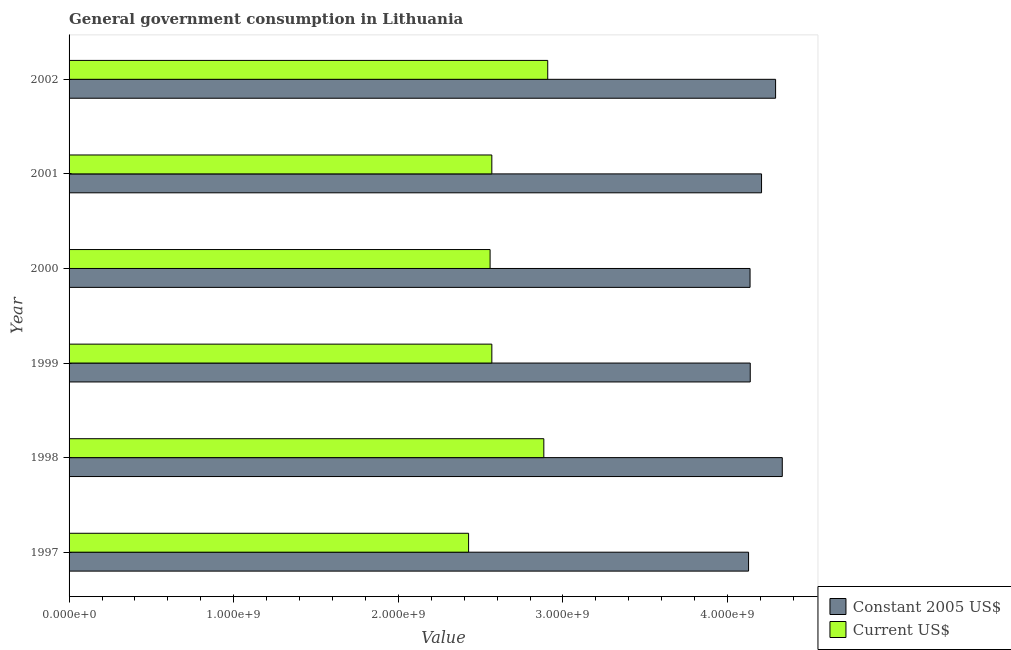Are the number of bars per tick equal to the number of legend labels?
Offer a very short reply. Yes. Are the number of bars on each tick of the Y-axis equal?
Provide a succinct answer. Yes. What is the value consumed in constant 2005 us$ in 2001?
Your answer should be compact. 4.21e+09. Across all years, what is the maximum value consumed in constant 2005 us$?
Offer a terse response. 4.33e+09. Across all years, what is the minimum value consumed in current us$?
Offer a terse response. 2.43e+09. In which year was the value consumed in constant 2005 us$ minimum?
Offer a terse response. 1997. What is the total value consumed in current us$ in the graph?
Ensure brevity in your answer.  1.59e+1. What is the difference between the value consumed in constant 2005 us$ in 1999 and that in 2001?
Your answer should be very brief. -6.86e+07. What is the difference between the value consumed in constant 2005 us$ in 1997 and the value consumed in current us$ in 2000?
Your answer should be compact. 1.57e+09. What is the average value consumed in constant 2005 us$ per year?
Offer a very short reply. 4.21e+09. In the year 2000, what is the difference between the value consumed in constant 2005 us$ and value consumed in current us$?
Keep it short and to the point. 1.58e+09. In how many years, is the value consumed in constant 2005 us$ greater than 3000000000 ?
Provide a succinct answer. 6. What is the ratio of the value consumed in constant 2005 us$ in 1997 to that in 1998?
Offer a very short reply. 0.95. What is the difference between the highest and the second highest value consumed in constant 2005 us$?
Provide a short and direct response. 4.07e+07. What is the difference between the highest and the lowest value consumed in constant 2005 us$?
Ensure brevity in your answer.  2.05e+08. In how many years, is the value consumed in current us$ greater than the average value consumed in current us$ taken over all years?
Your response must be concise. 2. What does the 2nd bar from the top in 2002 represents?
Offer a very short reply. Constant 2005 US$. What does the 1st bar from the bottom in 2001 represents?
Provide a succinct answer. Constant 2005 US$. How many bars are there?
Your response must be concise. 12. Are all the bars in the graph horizontal?
Offer a very short reply. Yes. How many legend labels are there?
Offer a very short reply. 2. What is the title of the graph?
Offer a terse response. General government consumption in Lithuania. Does "Public credit registry" appear as one of the legend labels in the graph?
Offer a terse response. No. What is the label or title of the X-axis?
Your answer should be very brief. Value. What is the label or title of the Y-axis?
Your response must be concise. Year. What is the Value of Constant 2005 US$ in 1997?
Provide a succinct answer. 4.13e+09. What is the Value in Current US$ in 1997?
Keep it short and to the point. 2.43e+09. What is the Value of Constant 2005 US$ in 1998?
Your answer should be very brief. 4.33e+09. What is the Value of Current US$ in 1998?
Your answer should be very brief. 2.88e+09. What is the Value of Constant 2005 US$ in 1999?
Make the answer very short. 4.14e+09. What is the Value in Current US$ in 1999?
Provide a succinct answer. 2.57e+09. What is the Value of Constant 2005 US$ in 2000?
Provide a short and direct response. 4.14e+09. What is the Value in Current US$ in 2000?
Make the answer very short. 2.56e+09. What is the Value of Constant 2005 US$ in 2001?
Ensure brevity in your answer.  4.21e+09. What is the Value of Current US$ in 2001?
Offer a very short reply. 2.57e+09. What is the Value of Constant 2005 US$ in 2002?
Keep it short and to the point. 4.29e+09. What is the Value in Current US$ in 2002?
Your answer should be very brief. 2.91e+09. Across all years, what is the maximum Value in Constant 2005 US$?
Your answer should be very brief. 4.33e+09. Across all years, what is the maximum Value of Current US$?
Your answer should be compact. 2.91e+09. Across all years, what is the minimum Value in Constant 2005 US$?
Provide a short and direct response. 4.13e+09. Across all years, what is the minimum Value in Current US$?
Your response must be concise. 2.43e+09. What is the total Value in Constant 2005 US$ in the graph?
Ensure brevity in your answer.  2.52e+1. What is the total Value of Current US$ in the graph?
Offer a very short reply. 1.59e+1. What is the difference between the Value in Constant 2005 US$ in 1997 and that in 1998?
Offer a very short reply. -2.05e+08. What is the difference between the Value of Current US$ in 1997 and that in 1998?
Give a very brief answer. -4.57e+08. What is the difference between the Value in Constant 2005 US$ in 1997 and that in 1999?
Provide a succinct answer. -1.02e+07. What is the difference between the Value in Current US$ in 1997 and that in 1999?
Ensure brevity in your answer.  -1.41e+08. What is the difference between the Value in Constant 2005 US$ in 1997 and that in 2000?
Keep it short and to the point. -9.15e+06. What is the difference between the Value in Current US$ in 1997 and that in 2000?
Keep it short and to the point. -1.31e+08. What is the difference between the Value of Constant 2005 US$ in 1997 and that in 2001?
Offer a very short reply. -7.89e+07. What is the difference between the Value in Current US$ in 1997 and that in 2001?
Provide a short and direct response. -1.41e+08. What is the difference between the Value of Constant 2005 US$ in 1997 and that in 2002?
Provide a short and direct response. -1.64e+08. What is the difference between the Value of Current US$ in 1997 and that in 2002?
Offer a very short reply. -4.81e+08. What is the difference between the Value in Constant 2005 US$ in 1998 and that in 1999?
Your answer should be very brief. 1.95e+08. What is the difference between the Value in Current US$ in 1998 and that in 1999?
Offer a very short reply. 3.16e+08. What is the difference between the Value of Constant 2005 US$ in 1998 and that in 2000?
Ensure brevity in your answer.  1.96e+08. What is the difference between the Value of Current US$ in 1998 and that in 2000?
Keep it short and to the point. 3.26e+08. What is the difference between the Value of Constant 2005 US$ in 1998 and that in 2001?
Your response must be concise. 1.26e+08. What is the difference between the Value in Current US$ in 1998 and that in 2001?
Keep it short and to the point. 3.16e+08. What is the difference between the Value of Constant 2005 US$ in 1998 and that in 2002?
Your answer should be compact. 4.07e+07. What is the difference between the Value of Current US$ in 1998 and that in 2002?
Your response must be concise. -2.38e+07. What is the difference between the Value in Constant 2005 US$ in 1999 and that in 2000?
Provide a succinct answer. 1.08e+06. What is the difference between the Value in Current US$ in 1999 and that in 2000?
Your answer should be compact. 1.06e+07. What is the difference between the Value of Constant 2005 US$ in 1999 and that in 2001?
Offer a very short reply. -6.86e+07. What is the difference between the Value of Current US$ in 1999 and that in 2001?
Your response must be concise. 8.89e+04. What is the difference between the Value in Constant 2005 US$ in 1999 and that in 2002?
Ensure brevity in your answer.  -1.54e+08. What is the difference between the Value in Current US$ in 1999 and that in 2002?
Keep it short and to the point. -3.40e+08. What is the difference between the Value of Constant 2005 US$ in 2000 and that in 2001?
Keep it short and to the point. -6.97e+07. What is the difference between the Value in Current US$ in 2000 and that in 2001?
Give a very brief answer. -1.05e+07. What is the difference between the Value of Constant 2005 US$ in 2000 and that in 2002?
Your response must be concise. -1.55e+08. What is the difference between the Value in Current US$ in 2000 and that in 2002?
Provide a succinct answer. -3.50e+08. What is the difference between the Value in Constant 2005 US$ in 2001 and that in 2002?
Keep it short and to the point. -8.53e+07. What is the difference between the Value in Current US$ in 2001 and that in 2002?
Provide a short and direct response. -3.40e+08. What is the difference between the Value of Constant 2005 US$ in 1997 and the Value of Current US$ in 1998?
Ensure brevity in your answer.  1.24e+09. What is the difference between the Value of Constant 2005 US$ in 1997 and the Value of Current US$ in 1999?
Ensure brevity in your answer.  1.56e+09. What is the difference between the Value in Constant 2005 US$ in 1997 and the Value in Current US$ in 2000?
Keep it short and to the point. 1.57e+09. What is the difference between the Value of Constant 2005 US$ in 1997 and the Value of Current US$ in 2001?
Offer a terse response. 1.56e+09. What is the difference between the Value in Constant 2005 US$ in 1997 and the Value in Current US$ in 2002?
Keep it short and to the point. 1.22e+09. What is the difference between the Value of Constant 2005 US$ in 1998 and the Value of Current US$ in 1999?
Provide a short and direct response. 1.76e+09. What is the difference between the Value of Constant 2005 US$ in 1998 and the Value of Current US$ in 2000?
Keep it short and to the point. 1.77e+09. What is the difference between the Value in Constant 2005 US$ in 1998 and the Value in Current US$ in 2001?
Keep it short and to the point. 1.76e+09. What is the difference between the Value of Constant 2005 US$ in 1998 and the Value of Current US$ in 2002?
Make the answer very short. 1.42e+09. What is the difference between the Value in Constant 2005 US$ in 1999 and the Value in Current US$ in 2000?
Offer a very short reply. 1.58e+09. What is the difference between the Value of Constant 2005 US$ in 1999 and the Value of Current US$ in 2001?
Your response must be concise. 1.57e+09. What is the difference between the Value of Constant 2005 US$ in 1999 and the Value of Current US$ in 2002?
Ensure brevity in your answer.  1.23e+09. What is the difference between the Value in Constant 2005 US$ in 2000 and the Value in Current US$ in 2001?
Your response must be concise. 1.57e+09. What is the difference between the Value of Constant 2005 US$ in 2000 and the Value of Current US$ in 2002?
Offer a very short reply. 1.23e+09. What is the difference between the Value of Constant 2005 US$ in 2001 and the Value of Current US$ in 2002?
Offer a very short reply. 1.30e+09. What is the average Value in Constant 2005 US$ per year?
Offer a very short reply. 4.21e+09. What is the average Value of Current US$ per year?
Offer a very short reply. 2.65e+09. In the year 1997, what is the difference between the Value of Constant 2005 US$ and Value of Current US$?
Provide a short and direct response. 1.70e+09. In the year 1998, what is the difference between the Value of Constant 2005 US$ and Value of Current US$?
Your response must be concise. 1.45e+09. In the year 1999, what is the difference between the Value in Constant 2005 US$ and Value in Current US$?
Your answer should be compact. 1.57e+09. In the year 2000, what is the difference between the Value of Constant 2005 US$ and Value of Current US$?
Provide a succinct answer. 1.58e+09. In the year 2001, what is the difference between the Value in Constant 2005 US$ and Value in Current US$?
Provide a short and direct response. 1.64e+09. In the year 2002, what is the difference between the Value in Constant 2005 US$ and Value in Current US$?
Your response must be concise. 1.38e+09. What is the ratio of the Value in Constant 2005 US$ in 1997 to that in 1998?
Provide a short and direct response. 0.95. What is the ratio of the Value in Current US$ in 1997 to that in 1998?
Give a very brief answer. 0.84. What is the ratio of the Value in Constant 2005 US$ in 1997 to that in 1999?
Provide a short and direct response. 1. What is the ratio of the Value in Current US$ in 1997 to that in 1999?
Your answer should be compact. 0.94. What is the ratio of the Value in Constant 2005 US$ in 1997 to that in 2000?
Your answer should be compact. 1. What is the ratio of the Value of Current US$ in 1997 to that in 2000?
Ensure brevity in your answer.  0.95. What is the ratio of the Value in Constant 2005 US$ in 1997 to that in 2001?
Your response must be concise. 0.98. What is the ratio of the Value in Current US$ in 1997 to that in 2001?
Give a very brief answer. 0.95. What is the ratio of the Value in Constant 2005 US$ in 1997 to that in 2002?
Give a very brief answer. 0.96. What is the ratio of the Value in Current US$ in 1997 to that in 2002?
Keep it short and to the point. 0.83. What is the ratio of the Value of Constant 2005 US$ in 1998 to that in 1999?
Your answer should be very brief. 1.05. What is the ratio of the Value of Current US$ in 1998 to that in 1999?
Your answer should be very brief. 1.12. What is the ratio of the Value in Constant 2005 US$ in 1998 to that in 2000?
Offer a terse response. 1.05. What is the ratio of the Value of Current US$ in 1998 to that in 2000?
Provide a short and direct response. 1.13. What is the ratio of the Value in Constant 2005 US$ in 1998 to that in 2001?
Provide a succinct answer. 1.03. What is the ratio of the Value in Current US$ in 1998 to that in 2001?
Make the answer very short. 1.12. What is the ratio of the Value in Constant 2005 US$ in 1998 to that in 2002?
Provide a succinct answer. 1.01. What is the ratio of the Value of Current US$ in 1999 to that in 2000?
Your response must be concise. 1. What is the ratio of the Value of Constant 2005 US$ in 1999 to that in 2001?
Keep it short and to the point. 0.98. What is the ratio of the Value of Constant 2005 US$ in 1999 to that in 2002?
Give a very brief answer. 0.96. What is the ratio of the Value in Current US$ in 1999 to that in 2002?
Make the answer very short. 0.88. What is the ratio of the Value of Constant 2005 US$ in 2000 to that in 2001?
Keep it short and to the point. 0.98. What is the ratio of the Value of Current US$ in 2000 to that in 2001?
Keep it short and to the point. 1. What is the ratio of the Value in Constant 2005 US$ in 2000 to that in 2002?
Offer a very short reply. 0.96. What is the ratio of the Value of Current US$ in 2000 to that in 2002?
Your answer should be compact. 0.88. What is the ratio of the Value in Constant 2005 US$ in 2001 to that in 2002?
Provide a short and direct response. 0.98. What is the ratio of the Value of Current US$ in 2001 to that in 2002?
Keep it short and to the point. 0.88. What is the difference between the highest and the second highest Value in Constant 2005 US$?
Offer a terse response. 4.07e+07. What is the difference between the highest and the second highest Value in Current US$?
Provide a succinct answer. 2.38e+07. What is the difference between the highest and the lowest Value in Constant 2005 US$?
Keep it short and to the point. 2.05e+08. What is the difference between the highest and the lowest Value of Current US$?
Provide a short and direct response. 4.81e+08. 